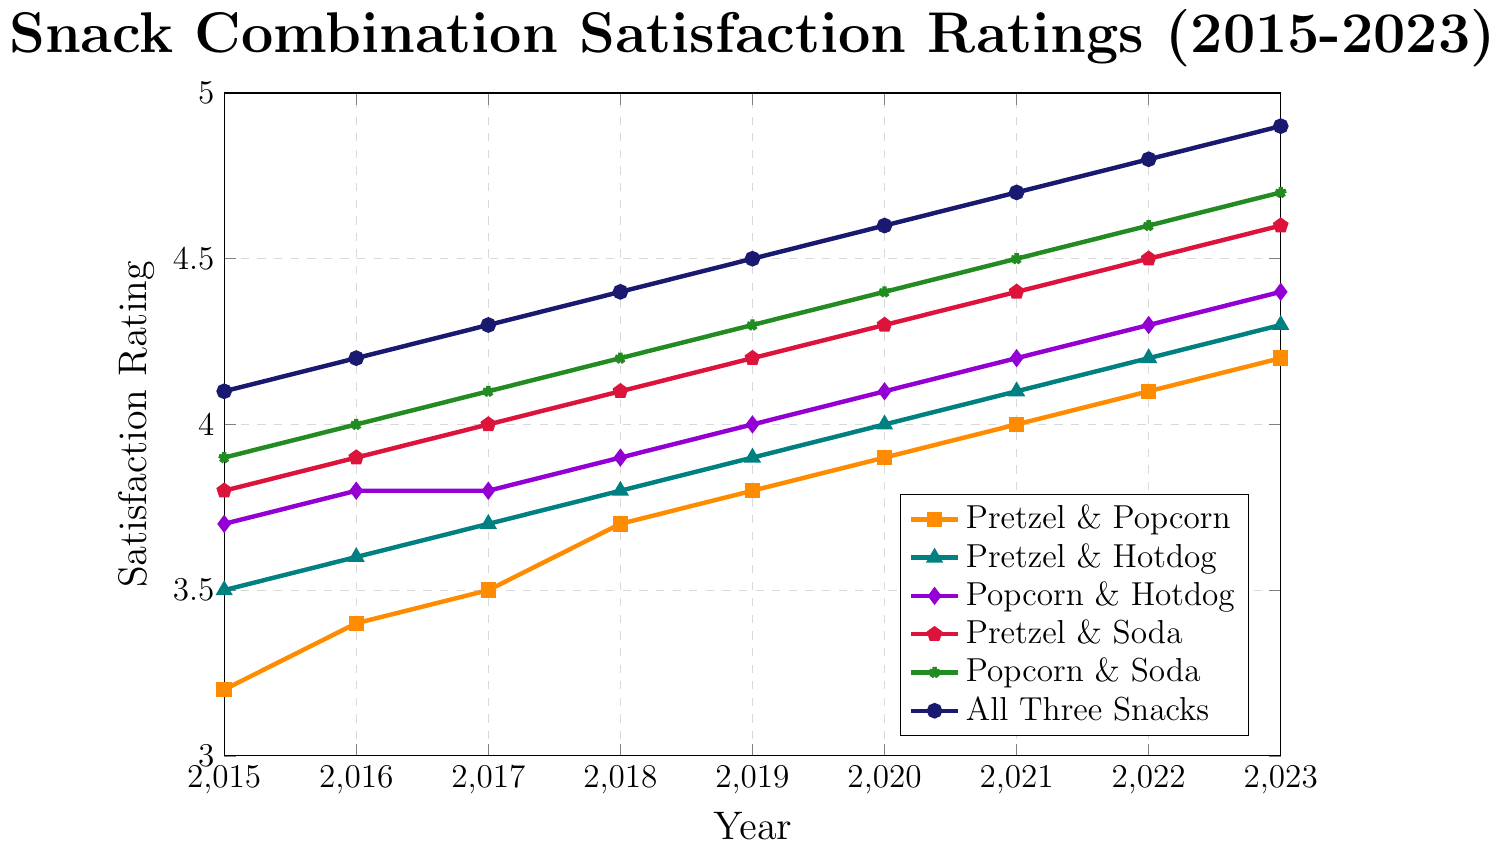what's the overall trend for the satisfaction ratings of 'All Three Snacks' from 2015 to 2023? Observing 'All Three Snacks' line, it consistently rises from 4.1 in 2015 to 4.9 in 2023. This indicates an increasing trend in customer satisfaction over time.
Answer: An increasing trend How much did the satisfaction rating for 'Pretzel & Soda' increase from 2015 to 2023? 'Pretzel & Soda' rating in 2015 was 3.8 and in 2023 it is 4.6. The increase is 4.6 - 3.8.
Answer: 0.8 Which snack combination had the highest satisfaction rating in 2018? Checking 2018 values, 'All Three Snacks' had the highest rating at 4.4.
Answer: All Three Snacks What’s the difference in satisfaction rating between 'Popcorn & Hotdog' and 'Pretzel & Popcorn' in 2023? In 2023, 'Popcorn & Hotdog' is rated 4.4 and 'Pretzel & Popcorn' is 4.2, making the difference 4.4 - 4.2.
Answer: 0.2 Which snack combination showed the smallest improvement in satisfaction rating from 2015 to 2023? Comparing the increases from 2015 to 2023 across all combinations, 'Pretzel & Popcorn' went from 3.2 to 4.2, an improvement of 1. This is the smallest improvement.
Answer: Pretzel & Popcorn What is the average satisfaction rating for 'Popcorn & Soda' from 2015 to 2018? Averaging 'Popcorn & Soda' ratings from 2015 (3.9), 2016 (4.0), 2017 (4.1), and 2018 (4.2) gives (3.9 + 4.0 + 4.1 + 4.2) / 4.
Answer: 4.05 In which year did 'Popcorn & Soda' surpass 'Pretzel & Hotdog' in satisfaction rating? Comparing yearly ratings, 'Popcorn & Soda' surpasses 'Pretzel & Hotdog' first in 2018, where it is 4.2 versus 3.8.
Answer: 2018 Which snack combination consistently had higher satisfaction ratings than 'Pretzel & Popcorn' every year? From 2015 to 2023, 'Popcorn & Soda' maintains a higher rating than 'Pretzel & Popcorn' each year.
Answer: Popcorn & Soda Between 2015 and 2020, which year had the largest increase in satisfaction rating for 'Pretzel & Hotdog'? Calculating yearly increases for 'Pretzel & Hotdog', 2017 to 2018 shows the largest increase, from 3.7 to 3.8.
Answer: 2017 to 2018 Was there any year where 'Pretzel & Soda' had the same satisfaction rating as 'Popcorn & Hotdog'? Checking yearly values, both 'Pretzel & Soda' and 'Popcorn & Hotdog' have 4.0 ratings in 2019.
Answer: 2019 